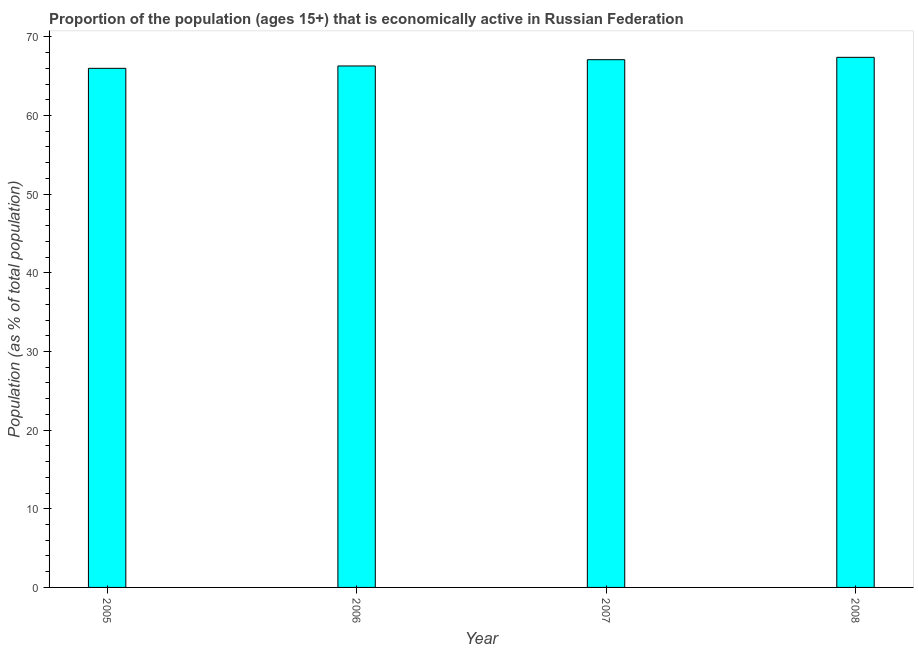Does the graph contain any zero values?
Offer a very short reply. No. Does the graph contain grids?
Your answer should be compact. No. What is the title of the graph?
Provide a short and direct response. Proportion of the population (ages 15+) that is economically active in Russian Federation. What is the label or title of the X-axis?
Your response must be concise. Year. What is the label or title of the Y-axis?
Offer a very short reply. Population (as % of total population). What is the percentage of economically active population in 2006?
Provide a succinct answer. 66.3. Across all years, what is the maximum percentage of economically active population?
Give a very brief answer. 67.4. Across all years, what is the minimum percentage of economically active population?
Offer a very short reply. 66. In which year was the percentage of economically active population maximum?
Your response must be concise. 2008. What is the sum of the percentage of economically active population?
Make the answer very short. 266.8. What is the average percentage of economically active population per year?
Your answer should be compact. 66.7. What is the median percentage of economically active population?
Provide a short and direct response. 66.7. Is the sum of the percentage of economically active population in 2006 and 2007 greater than the maximum percentage of economically active population across all years?
Provide a short and direct response. Yes. How many bars are there?
Make the answer very short. 4. Are all the bars in the graph horizontal?
Ensure brevity in your answer.  No. How many years are there in the graph?
Your answer should be very brief. 4. Are the values on the major ticks of Y-axis written in scientific E-notation?
Offer a very short reply. No. What is the Population (as % of total population) in 2006?
Make the answer very short. 66.3. What is the Population (as % of total population) in 2007?
Ensure brevity in your answer.  67.1. What is the Population (as % of total population) in 2008?
Offer a very short reply. 67.4. What is the difference between the Population (as % of total population) in 2005 and 2007?
Your answer should be very brief. -1.1. What is the difference between the Population (as % of total population) in 2005 and 2008?
Offer a very short reply. -1.4. What is the difference between the Population (as % of total population) in 2006 and 2008?
Your answer should be compact. -1.1. What is the difference between the Population (as % of total population) in 2007 and 2008?
Ensure brevity in your answer.  -0.3. What is the ratio of the Population (as % of total population) in 2005 to that in 2006?
Offer a terse response. 0.99. What is the ratio of the Population (as % of total population) in 2005 to that in 2007?
Your answer should be compact. 0.98. What is the ratio of the Population (as % of total population) in 2006 to that in 2007?
Ensure brevity in your answer.  0.99. What is the ratio of the Population (as % of total population) in 2006 to that in 2008?
Keep it short and to the point. 0.98. What is the ratio of the Population (as % of total population) in 2007 to that in 2008?
Provide a succinct answer. 1. 